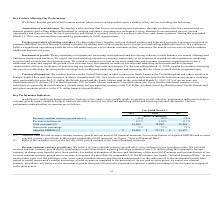According to Mimecast Limited's financial document, How is Adjusted EBITDA defined? Based on the financial document, the answer is net (loss) income, adjusted to exclude: depreciation, amortization, disposals and impairment of long-lived assets, acquisition-related gains and expenses, litigation-related expenses, share-based compensation expense, restructuring expense, interest income and interest expense, the provision for income taxes and foreign exchange income (expense).. Also, What was the Revenue constant currency growth rate in 2019, 2018 and 2017 respectively? The document contains multiple relevant values: 32%, 38%, 39%. From the document: "Revenue constant currency growth rate (1) 32% 38% 39% Revenue constant currency growth rate (1) 32% 38% 39% Revenue constant currency growth rate (1) ..." Also, What was the Revenue retention rate in 2019, 2018 and 2017 respectively? The document contains multiple relevant values: 111%, 110%, 111%. From the document: "Revenue retention rate 111% 110% 111% Revenue retention rate 111% 110% 111%..." Also, can you calculate: What is the change in the Revenue constant currency growth rate from 2018 to 2019? Based on the calculation: 32 - 38, the result is -6 (percentage). This is based on the information: "Revenue constant currency growth rate (1) 32% 38% 39% Revenue constant currency growth rate (1) 32% 38% 39%..." The key data points involved are: 32, 38. Also, can you calculate: What is the average Total customers between 2017-2019? To answer this question, I need to perform calculations using the financial data. The calculation is: (34,400 + 30,400 + 26,400) / 3, which equals 30400. This is based on the information: "Total customers (2) 34,400 30,400 26,400 Total customers (2) 34,400 30,400 26,400 Total customers (2) 34,400 30,400 26,400..." The key data points involved are: 26,400, 30,400, 34,400. Additionally, In which year was Adjusted EBITDA less than 20,000 thousands? According to the financial document, 2017. The relevant text states: "2019 2018 2017..." 